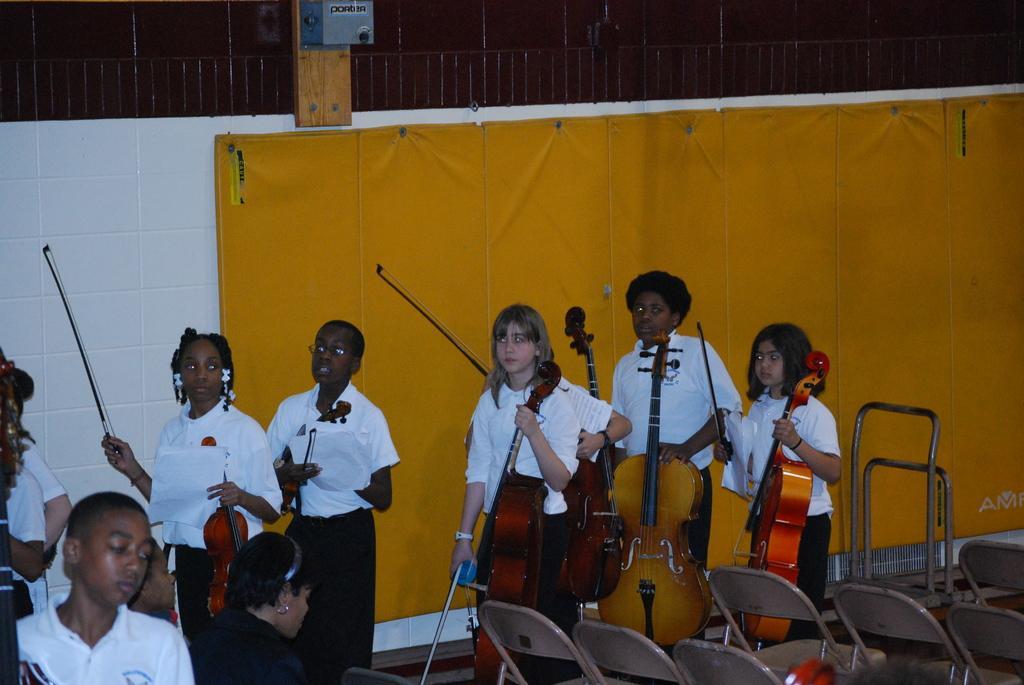Could you give a brief overview of what you see in this image? In this image I can see number of people are standing and holding musical instruments. Here I can see few chairs. 